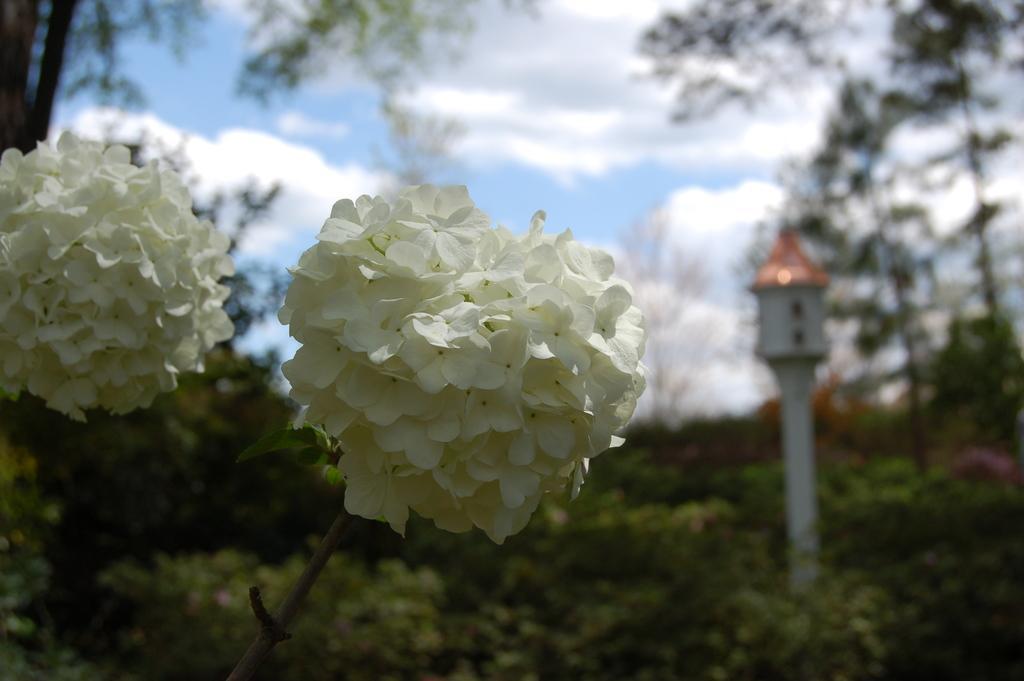How would you summarize this image in a sentence or two? In the image we can see the flowers, white in color. Here we can see trees, pole and the cloudy sky. The background is slightly blurred. 